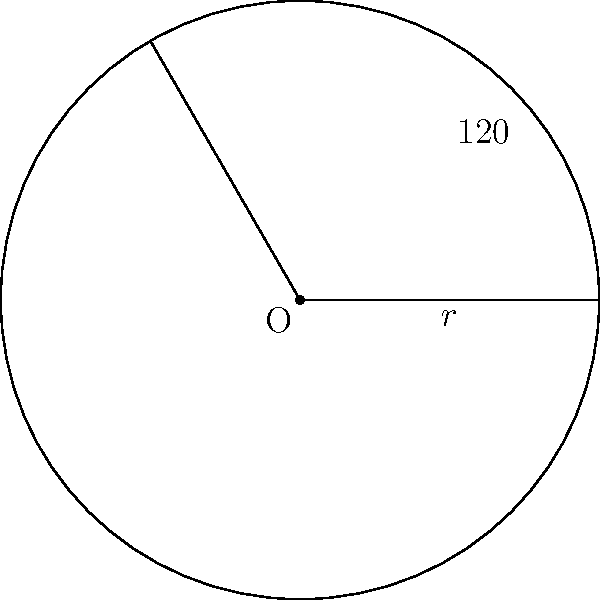In a circular sector with radius $r = 5$ cm and central angle $120°$, what is the area of the sector? Round your answer to two decimal places. To find the area of a circular sector, we can follow these steps:

1. Recall the formula for the area of a circular sector:
   $$A = \frac{\theta}{360°} \pi r^2$$
   where $A$ is the area, $\theta$ is the central angle in degrees, and $r$ is the radius.

2. We are given:
   $r = 5$ cm
   $\theta = 120°$

3. Substitute these values into the formula:
   $$A = \frac{120°}{360°} \pi (5 \text{ cm})^2$$

4. Simplify:
   $$A = \frac{1}{3} \pi (25 \text{ cm}^2)$$

5. Calculate:
   $$A = \frac{1}{3} \times 3.14159 \times 25 \text{ cm}^2 \approx 26.18 \text{ cm}^2$$

6. Round to two decimal places:
   $$A \approx 26.18 \text{ cm}^2$$
Answer: $26.18 \text{ cm}^2$ 